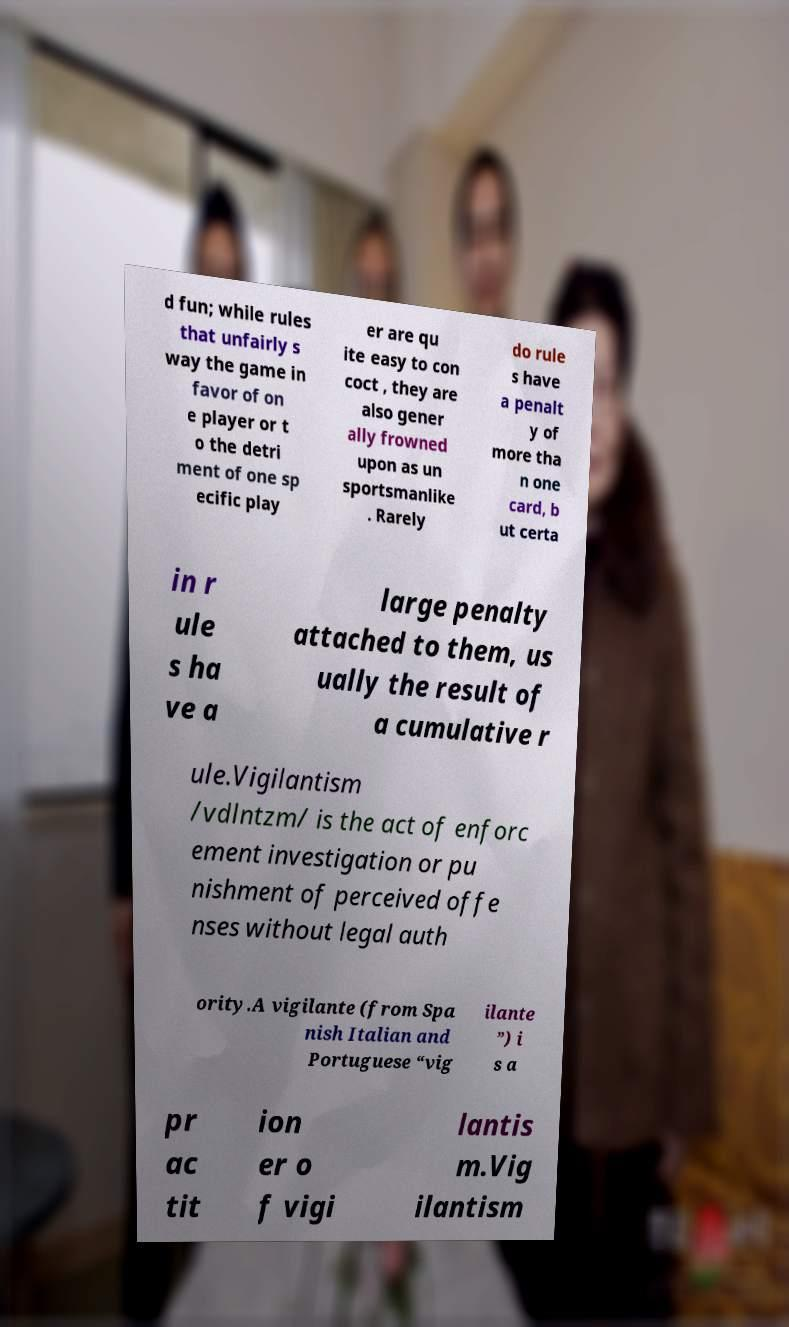For documentation purposes, I need the text within this image transcribed. Could you provide that? d fun; while rules that unfairly s way the game in favor of on e player or t o the detri ment of one sp ecific play er are qu ite easy to con coct , they are also gener ally frowned upon as un sportsmanlike . Rarely do rule s have a penalt y of more tha n one card, b ut certa in r ule s ha ve a large penalty attached to them, us ually the result of a cumulative r ule.Vigilantism /vdlntzm/ is the act of enforc ement investigation or pu nishment of perceived offe nses without legal auth ority.A vigilante (from Spa nish Italian and Portuguese “vig ilante ”) i s a pr ac tit ion er o f vigi lantis m.Vig ilantism 